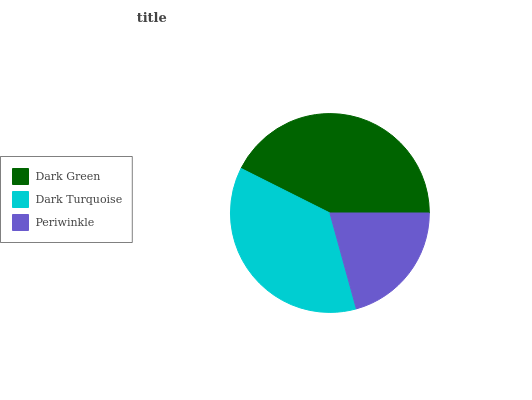Is Periwinkle the minimum?
Answer yes or no. Yes. Is Dark Green the maximum?
Answer yes or no. Yes. Is Dark Turquoise the minimum?
Answer yes or no. No. Is Dark Turquoise the maximum?
Answer yes or no. No. Is Dark Green greater than Dark Turquoise?
Answer yes or no. Yes. Is Dark Turquoise less than Dark Green?
Answer yes or no. Yes. Is Dark Turquoise greater than Dark Green?
Answer yes or no. No. Is Dark Green less than Dark Turquoise?
Answer yes or no. No. Is Dark Turquoise the high median?
Answer yes or no. Yes. Is Dark Turquoise the low median?
Answer yes or no. Yes. Is Dark Green the high median?
Answer yes or no. No. Is Periwinkle the low median?
Answer yes or no. No. 